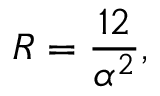Convert formula to latex. <formula><loc_0><loc_0><loc_500><loc_500>R = \frac { 1 2 } { \alpha ^ { 2 } } ,</formula> 